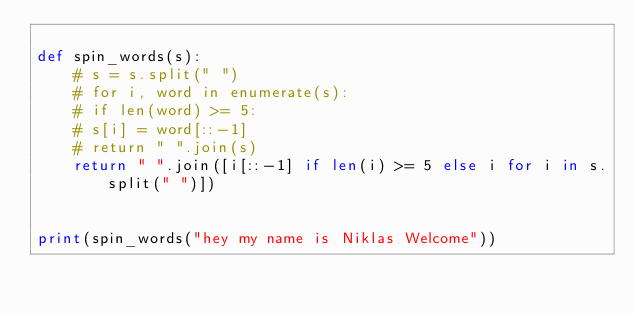Convert code to text. <code><loc_0><loc_0><loc_500><loc_500><_Python_>
def spin_words(s):
    # s = s.split(" ")
    # for i, word in enumerate(s):
    # if len(word) >= 5:
    # s[i] = word[::-1]
    # return " ".join(s)
    return " ".join([i[::-1] if len(i) >= 5 else i for i in s.split(" ")])


print(spin_words("hey my name is Niklas Welcome"))</code> 